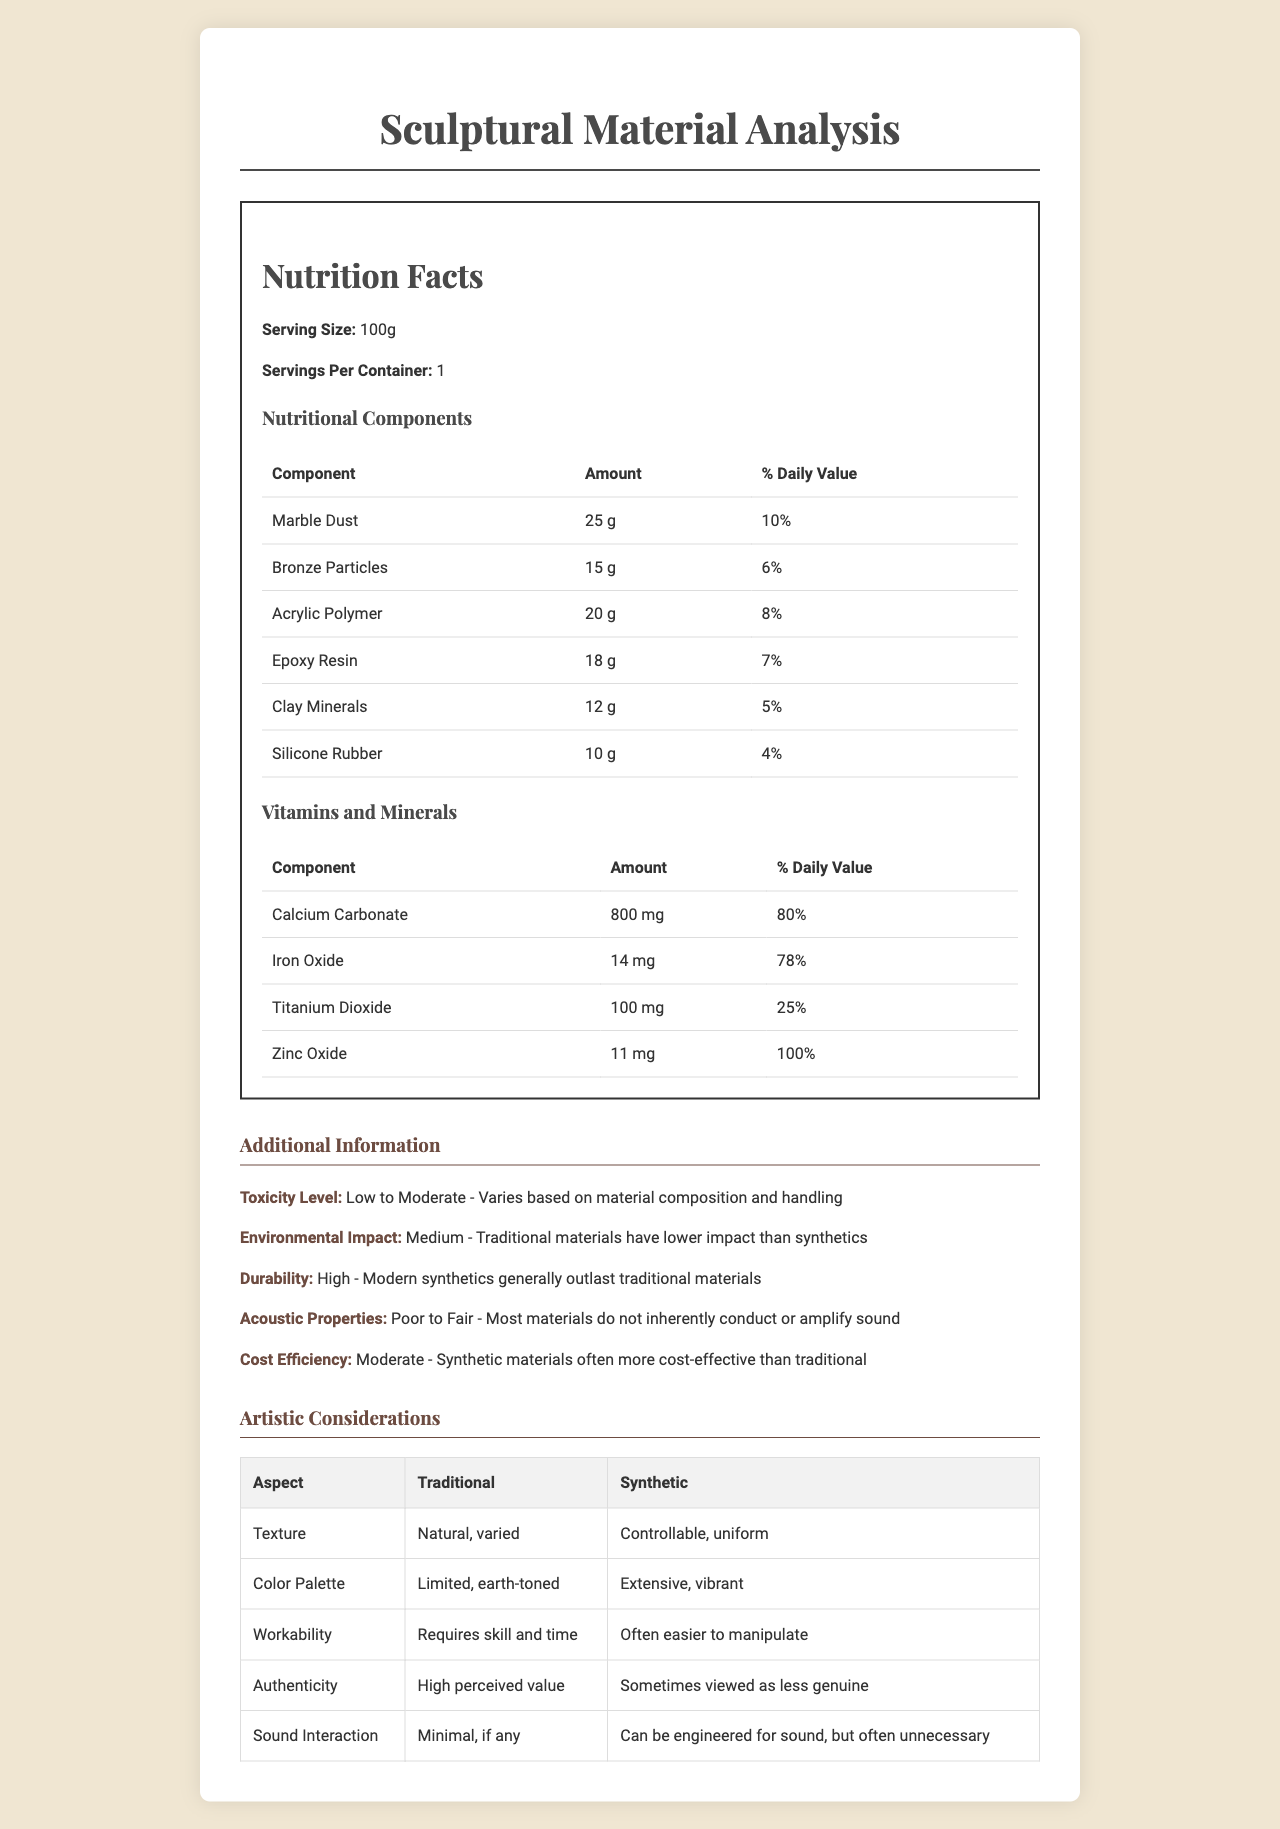what is the serving size? The serving size is clearly stated to be 100g in the "Nutrition Facts" section of the document.
Answer: 100g how much Marble Dust does the material contain? The "Nutritional Components" table lists Marble Dust as containing 25g in the material.
Answer: 25g what is the daily value percentage of Iron Oxide? The "Vitamins and Minerals" table lists Iron Oxide with a daily value of 78%.
Answer: 78% which component has the highest amount in mg? The "Vitamins and Minerals" table shows Calcium Carbonate has the highest amount at 800mg.
Answer: Calcium Carbonate how does the environmental impact compare between traditional and synthetic materials? The "Additional Information" section mentions that traditional materials have lower impact than synthetics.
Answer: Traditional materials have a lower impact compared to synthetics. which material has the highest daily value percentage in the nutritional components? A. Marble Dust B. Bronze Particles C. Acrylic Polymer D. Epoxy Resin Marble Dust has the highest daily value percentage at 10% in the "Nutritional Components" table.
Answer: A. Marble Dust what is the durability rating of modern synthetics? A. Medium B. Low C. High D. Very High The "Additional Information" section states that modern synthetics generally have high durability.
Answer: C. High is the toxic level high for these materials? The "Additional Information" section describes the toxicity level as "Low to Moderate."
Answer: No summarize the main differences in artistic considerations between traditional and synthetic materials. These insights come from the "Artistic Considerations" table, which contrasts various aspects of traditional and synthetic materials.
Answer: Traditional materials have natural, varied textures and a limited earth-toned color palette, whereas synthetic materials offer controllable and uniform textures with an extensive, vibrant color palette. Traditional materials are perceived to have high authenticity but require more skill and time to work with, whereas synthetics are easier to manipulate but sometimes seen as less genuine. Synthetic materials can be engineered for sound but traditional materials typically have minimal sound interaction. what is not mentioned about the cost of traditional materials compared to synthetics? The document does mention that synthetic materials are often more cost-effective but does not provide specific cost details for traditional materials, making it impossible to determine the exact comparison.
Answer: Not enough information 